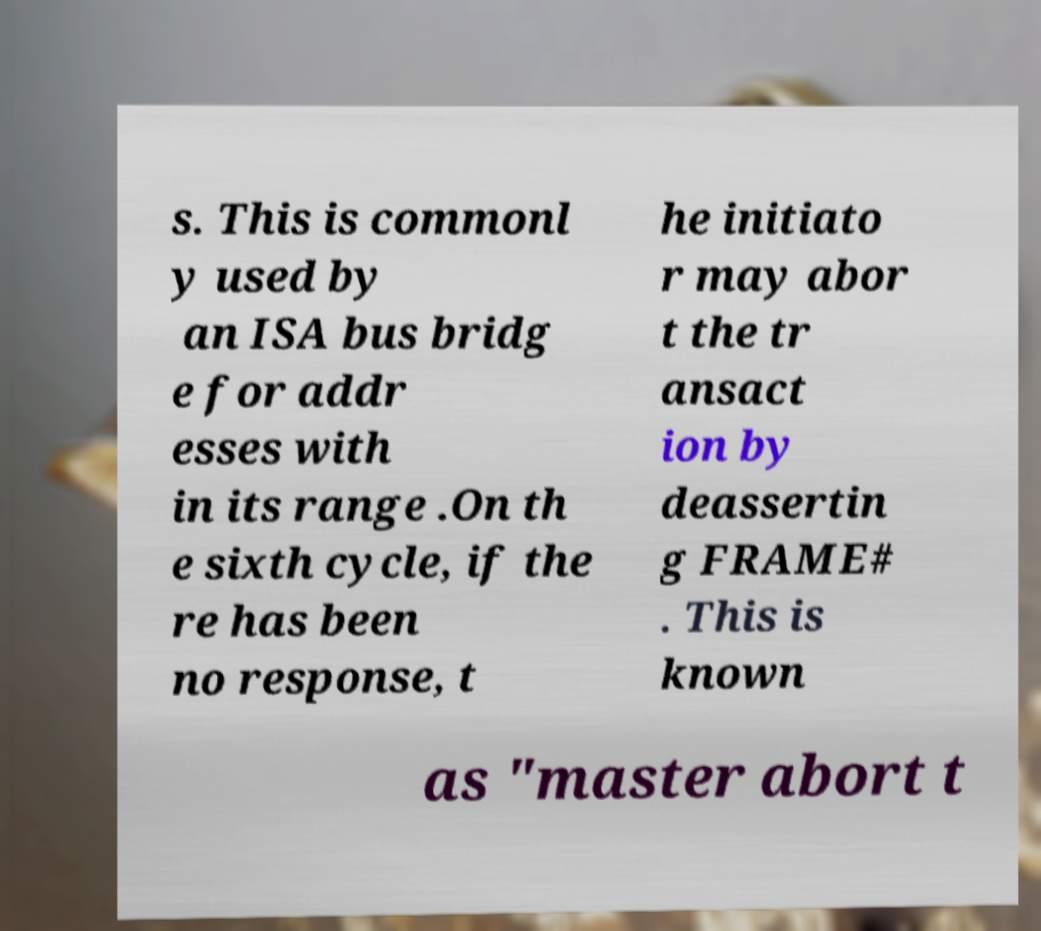Could you assist in decoding the text presented in this image and type it out clearly? s. This is commonl y used by an ISA bus bridg e for addr esses with in its range .On th e sixth cycle, if the re has been no response, t he initiato r may abor t the tr ansact ion by deassertin g FRAME# . This is known as "master abort t 